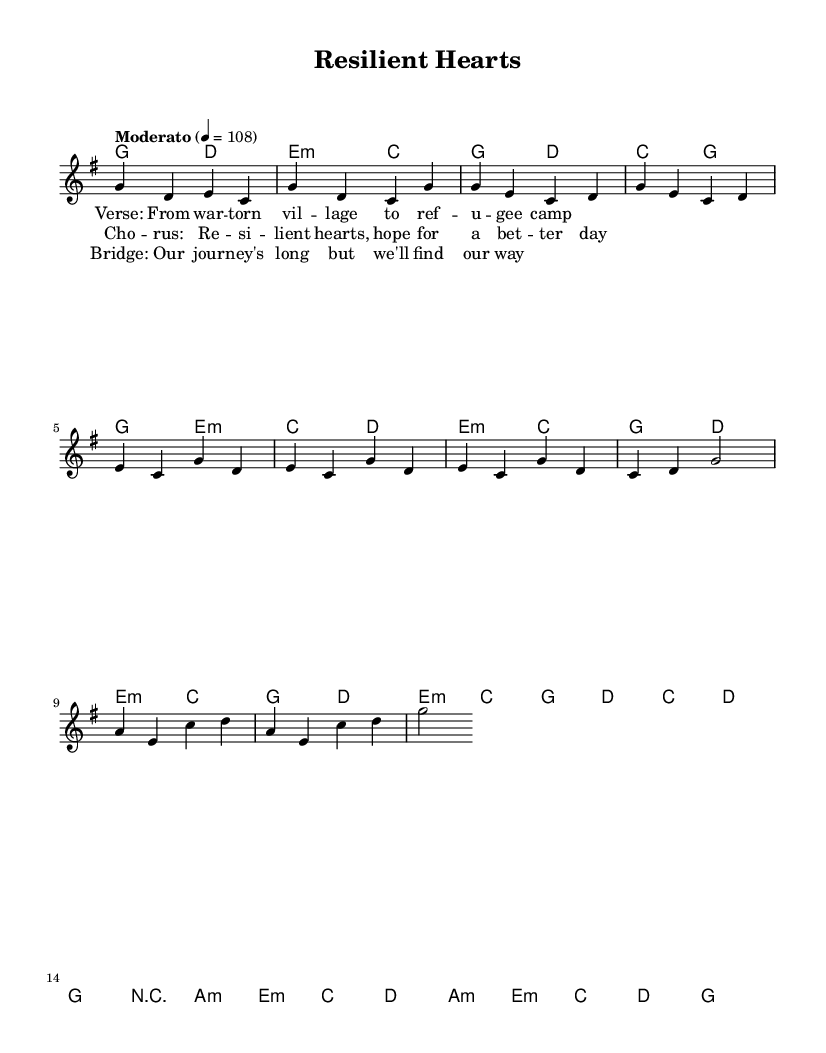What is the key signature of this music? The key signature is G major, which has one sharp (F#). This can be identified at the beginning of the sheet music under the clef sign.
Answer: G major What is the time signature of this music? The time signature is 4/4, meaning there are four beats in every measure and the quarter note gets one beat. This is indicated at the beginning of the sheet music after the key signature.
Answer: 4/4 What is the tempo marking for this piece? The tempo marking is "Moderato" at a speed of 108 beats per minute. This is found in the instructions at the start of the score.
Answer: Moderato, 108 How many measures are in the chorus section? The chorus section contains 8 measures, as counted from the sheet music notation and the placement of the lyrics associated with this section.
Answer: 8 What is the harmonic progression in the chorus? The harmonic progression alternates between E minor and C major, then G major and D major throughout the 8 measures. This can be deduced by analyzing the chord symbols above the melody lines in the chorus.
Answer: E minor, C major, G major, D major What is the theme of the lyrics in this ballad? The theme revolves around resilience and hope, concerning refugee experiences from the lyrics provided in the placeholder sections. This theme aligns with the idea presented through folk-punk music, often characterized by storytelling about struggle and perseverance.
Answer: Resilience and hope What instrument is primarily featured in this score? The primary instrument featured in this score is a guitar, which is common in folk-punk music for accompanying melodies and providing rhythm. This can be inferred from the chord notation style used, typical for guitar playing in this genre.
Answer: Guitar 